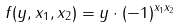<formula> <loc_0><loc_0><loc_500><loc_500>f ( y , x _ { 1 } , x _ { 2 } ) = y \cdot ( - 1 ) ^ { x _ { 1 } x _ { 2 } }</formula> 